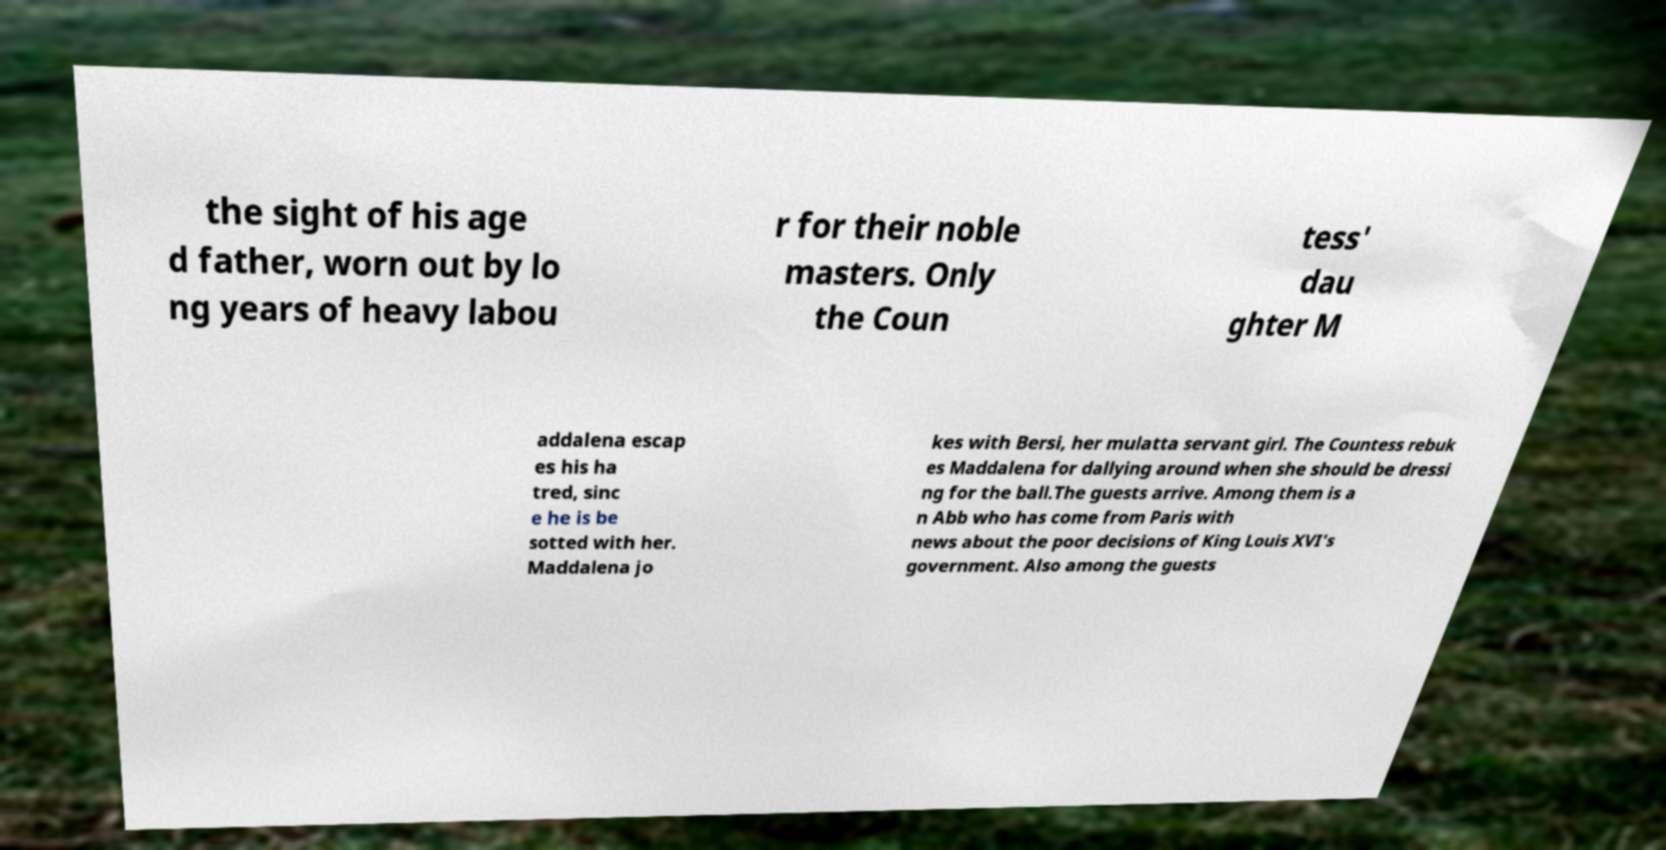Can you accurately transcribe the text from the provided image for me? the sight of his age d father, worn out by lo ng years of heavy labou r for their noble masters. Only the Coun tess' dau ghter M addalena escap es his ha tred, sinc e he is be sotted with her. Maddalena jo kes with Bersi, her mulatta servant girl. The Countess rebuk es Maddalena for dallying around when she should be dressi ng for the ball.The guests arrive. Among them is a n Abb who has come from Paris with news about the poor decisions of King Louis XVI's government. Also among the guests 